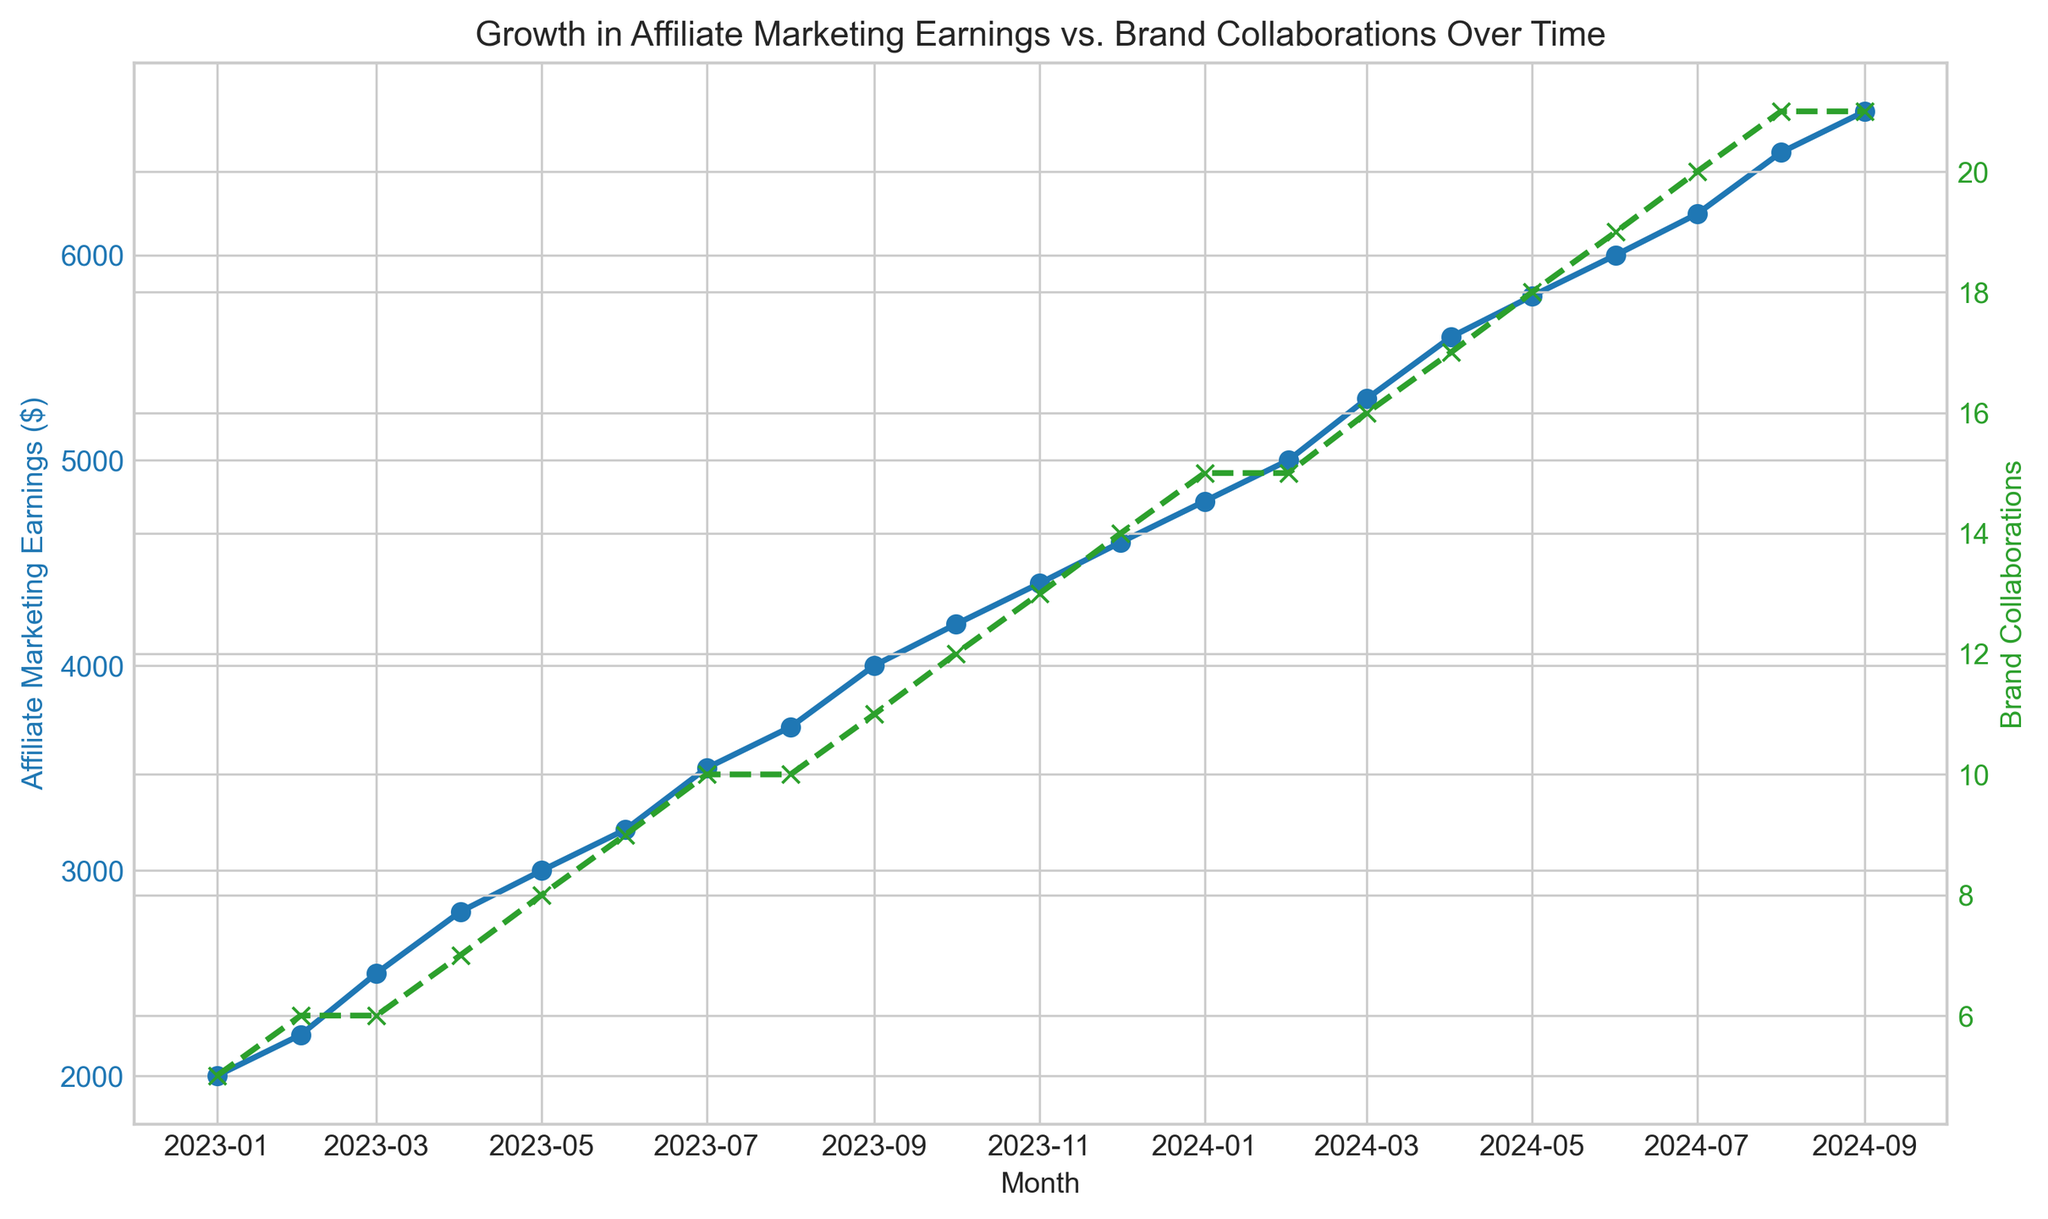What is the trend of Affiliate Marketing Earnings over the given period? To identify the trend, observe the blue line representing earnings over time. The line consistently ascends, indicating a continuous increase in earnings from January 2023 to September 2024.
Answer: Increasing During which month do Brand Collaborations reach 15? Brand Collaborations are represented by the green dashed line. Follow the line until it intersects the horizontal axis marked 15. This occurs in January 2024 and February 2024.
Answer: January 2024 and February 2024 What is the difference in Affiliate Marketing Earnings between January 2023 and January 2024? Affiliate Marketing Earnings in January 2023 are $2000, while in January 2024, they are $4800. Subtract the earlier value from the later one: $4800 - $2000 = $2800.
Answer: $2800 How do the numbers of Brand Collaborations in January 2024 and January 2023 compare? In January 2023, Brand Collaborations are 5, and in January 2024, they are 15. January 2024 has significantly more collaborations.
Answer: January 2024 has more collaborations Is there a month where Affiliate Marketing Earnings and Brand Collaborations both remain constant? Examine both lines for any flat segments. Between February 2024 and March 2024, affiliate earnings increase, but brand collaborations remain constant at 15.
Answer: No In which month do Affiliate Marketing Earnings first exceed 4000? Follow the blue line to the point where it first crosses the $4000 mark. This occurs in September 2023.
Answer: September 2023 Between which months is the steepest increase in Brand Collaborations? Identify the steepest slope of the green dashed line. The segment between December 2023 (14) and January 2024 (15) shows the most significant increase in a single month.
Answer: December 2023 to January 2024 What is the average number of Brand Collaborations in 2023? Sum the collaborations for each month in 2023: 5+6+6+7+8+9+10+10+11+12+13+14. There are 12 months, so: (5+6+6+7+8+9+10+10+11+12+13+14)/12 = 9.58.
Answer: 9.58 Which period shows the most consistent growth in Affiliate Marketing Earnings? Consider the periods where the blue line shows a steady increase without much fluctuation. February 2023 to October 2023 and February 2024 to August 2024 are both consistent, but the second period has more data points.
Answer: February 2024 to August 2024 What color line represents Brand Collaborations, and what's its style? The green dashed line represents Brand Collaborations, with "x" markers.
Answer: Green dashed line 